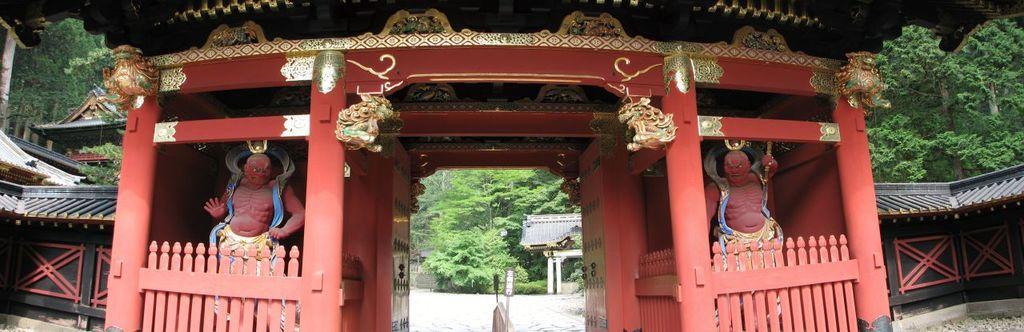Could you give a brief overview of what you see in this image? In this image, we can see an arch contains sculptures. There is a shelter house on the left side of the image. In the background of the image, there are some trees. 